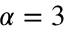<formula> <loc_0><loc_0><loc_500><loc_500>\alpha = 3</formula> 